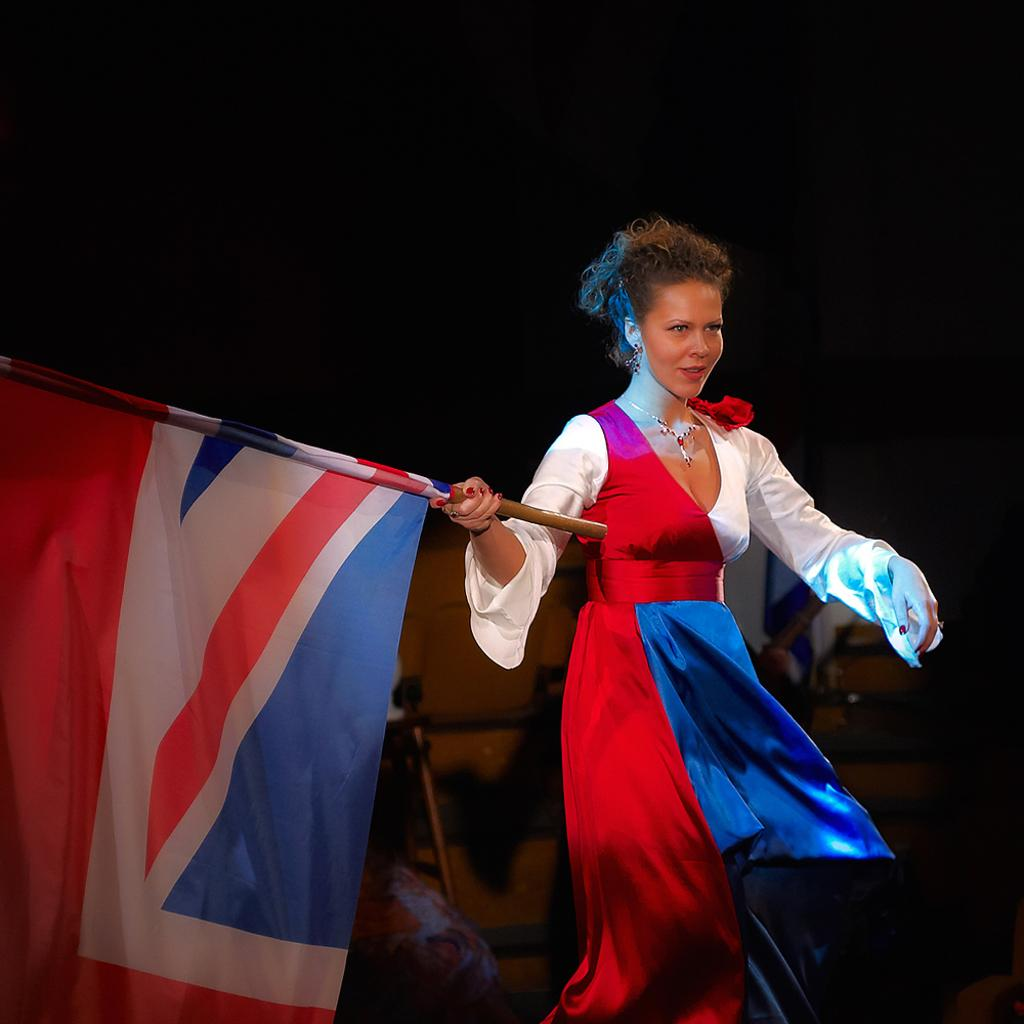Who is the main subject in the image? There is a woman in the image. What is the woman holding in the image? The woman is holding a flag with a pole. Can you describe the background of the image? The background of the image has a blurred view. What else can be seen in the image besides the woman and the flag? There are objects visible in the image. How would you describe the top part of the image? The top of the image has a dark view. What type of railway can be seen in the image? There is no railway present in the image. What color is the bike in the image? There is no bike present in the image. 